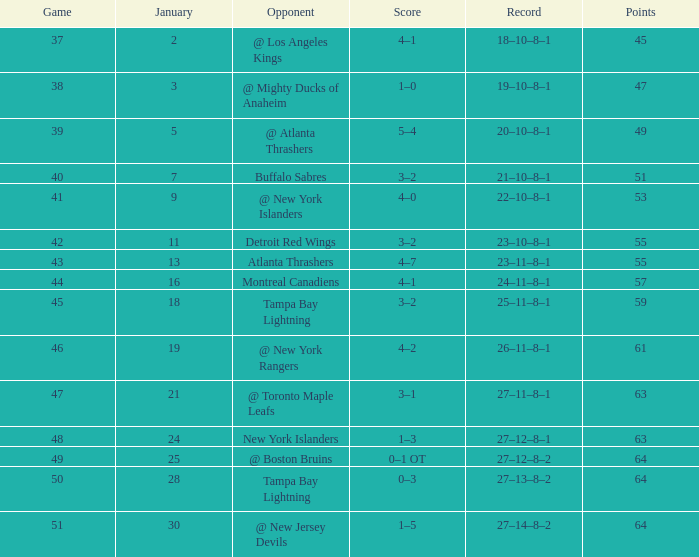How many games possess a score of 5-4, and points less than 49? 0.0. 